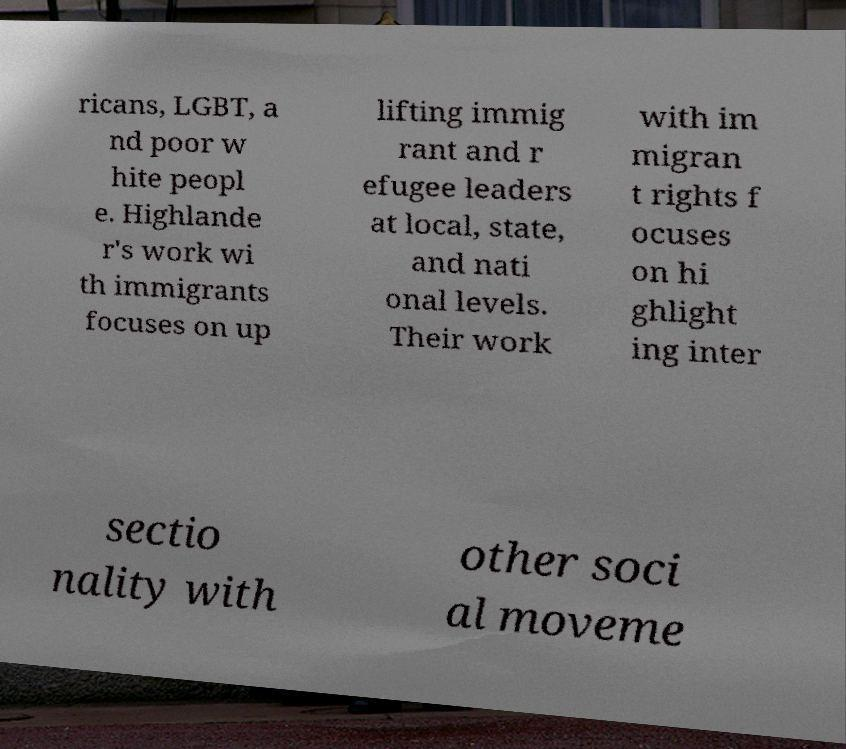For documentation purposes, I need the text within this image transcribed. Could you provide that? ricans, LGBT, a nd poor w hite peopl e. Highlande r's work wi th immigrants focuses on up lifting immig rant and r efugee leaders at local, state, and nati onal levels. Their work with im migran t rights f ocuses on hi ghlight ing inter sectio nality with other soci al moveme 